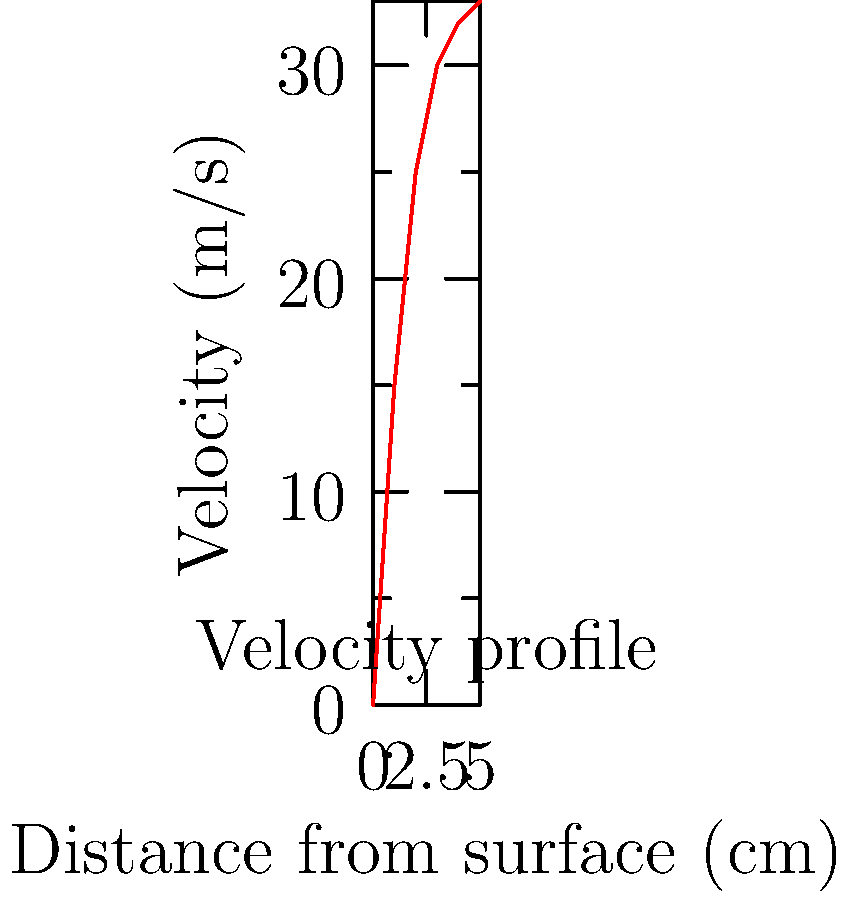As a sports commentator, you're asked to explain the concept of drag force to your audience using a wind tunnel experiment. Given the velocity profile in the graph, estimate the drag force on a streamlined object with a frontal area of 0.1 m² if the air density is 1.2 kg/m³. Assume the boundary layer thickness is 5 cm and the freestream velocity is 33 m/s. Let's break this down step-by-step:

1) The drag force formula is:
   $$F_D = \frac{1}{2} \rho V^2 A C_D$$
   where $\rho$ is air density, $V$ is freestream velocity, $A$ is frontal area, and $C_D$ is the drag coefficient.

2) We're given:
   $\rho = 1.2$ kg/m³
   $A = 0.1$ m²
   $V = 33$ m/s (freestream velocity)

3) To find $C_D$, we can use the momentum thickness formula:
   $$\theta = \int_0^\delta \frac{u}{U_\infty}(1-\frac{u}{U_\infty}) dy$$
   where $\delta$ is the boundary layer thickness (5 cm) and $u$ is the local velocity.

4) Using the trapezoidal rule to approximate the integral:
   $$\theta \approx \frac{1}{2} \sum_{i=1}^n (y_i - y_{i-1})(\frac{u_i}{U_\infty}(1-\frac{u_i}{U_\infty}) + \frac{u_{i-1}}{U_\infty}(1-\frac{u_{i-1}}{U_\infty}))$$

5) Calculating this (you would normally use a computer):
   $$\theta \approx 0.00534$$ m

6) The drag coefficient for a flat plate is approximately:
   $$C_D \approx \frac{2\theta}{L}$$
   where $L$ is the length of the plate. Assuming $L = 1$ m:
   $$C_D \approx 2 * 0.00534 = 0.01068$$

7) Now we can calculate the drag force:
   $$F_D = \frac{1}{2} * 1.2 * 33^2 * 0.1 * 0.01068 \approx 0.70$$ N
Answer: 0.70 N 